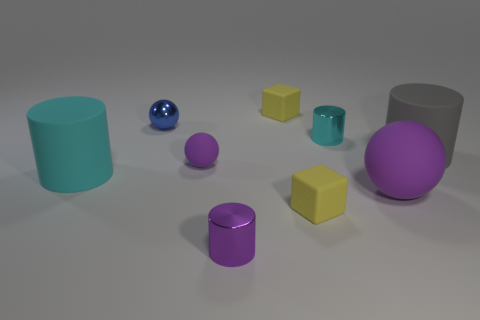Subtract all rubber balls. How many balls are left? 1 Subtract all brown cubes. How many purple balls are left? 2 Subtract all gray cylinders. How many cylinders are left? 3 Subtract 2 cylinders. How many cylinders are left? 2 Subtract 0 yellow cylinders. How many objects are left? 9 Subtract all cylinders. How many objects are left? 5 Subtract all green cylinders. Subtract all green balls. How many cylinders are left? 4 Subtract all green metal blocks. Subtract all metallic cylinders. How many objects are left? 7 Add 4 purple matte spheres. How many purple matte spheres are left? 6 Add 7 small cyan rubber cylinders. How many small cyan rubber cylinders exist? 7 